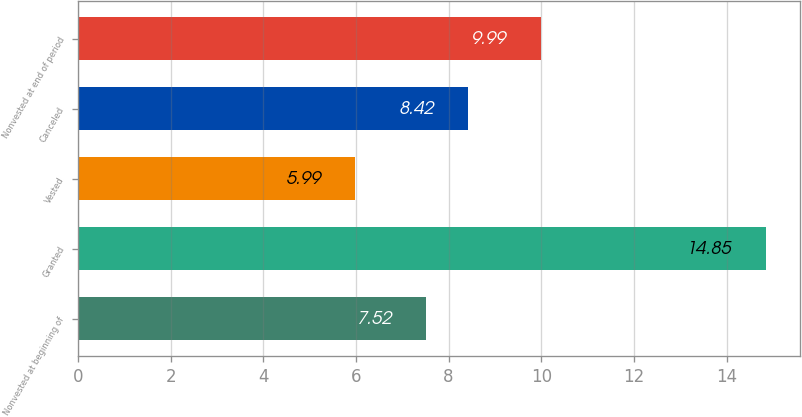<chart> <loc_0><loc_0><loc_500><loc_500><bar_chart><fcel>Nonvested at beginning of<fcel>Granted<fcel>Vested<fcel>Canceled<fcel>Nonvested at end of period<nl><fcel>7.52<fcel>14.85<fcel>5.99<fcel>8.42<fcel>9.99<nl></chart> 